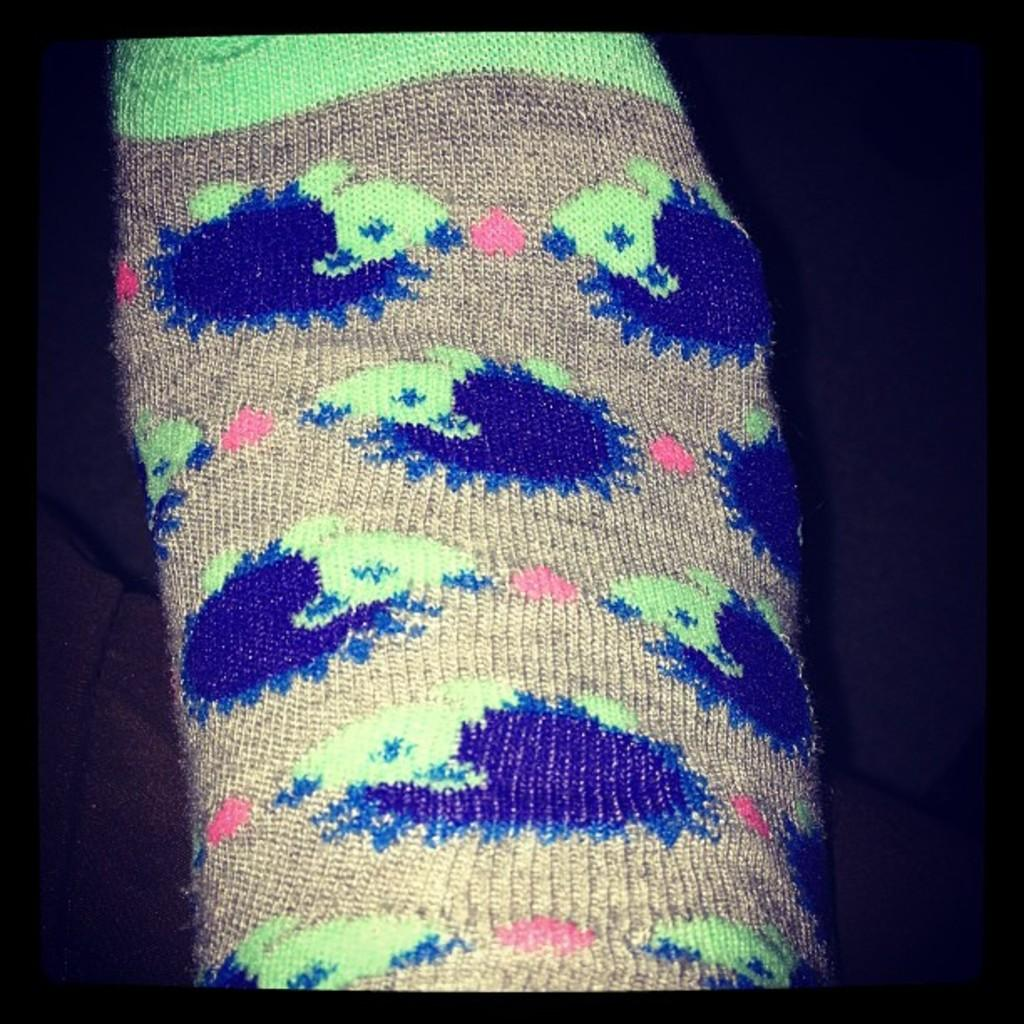What type of material is featured in the image? There is a woollen cloth in the image. What type of meeting is taking place in the image? There is no meeting present in the image; it only features a woollen cloth. How old is the boy in the image? There is no boy present in the image; it only features a woollen cloth. 